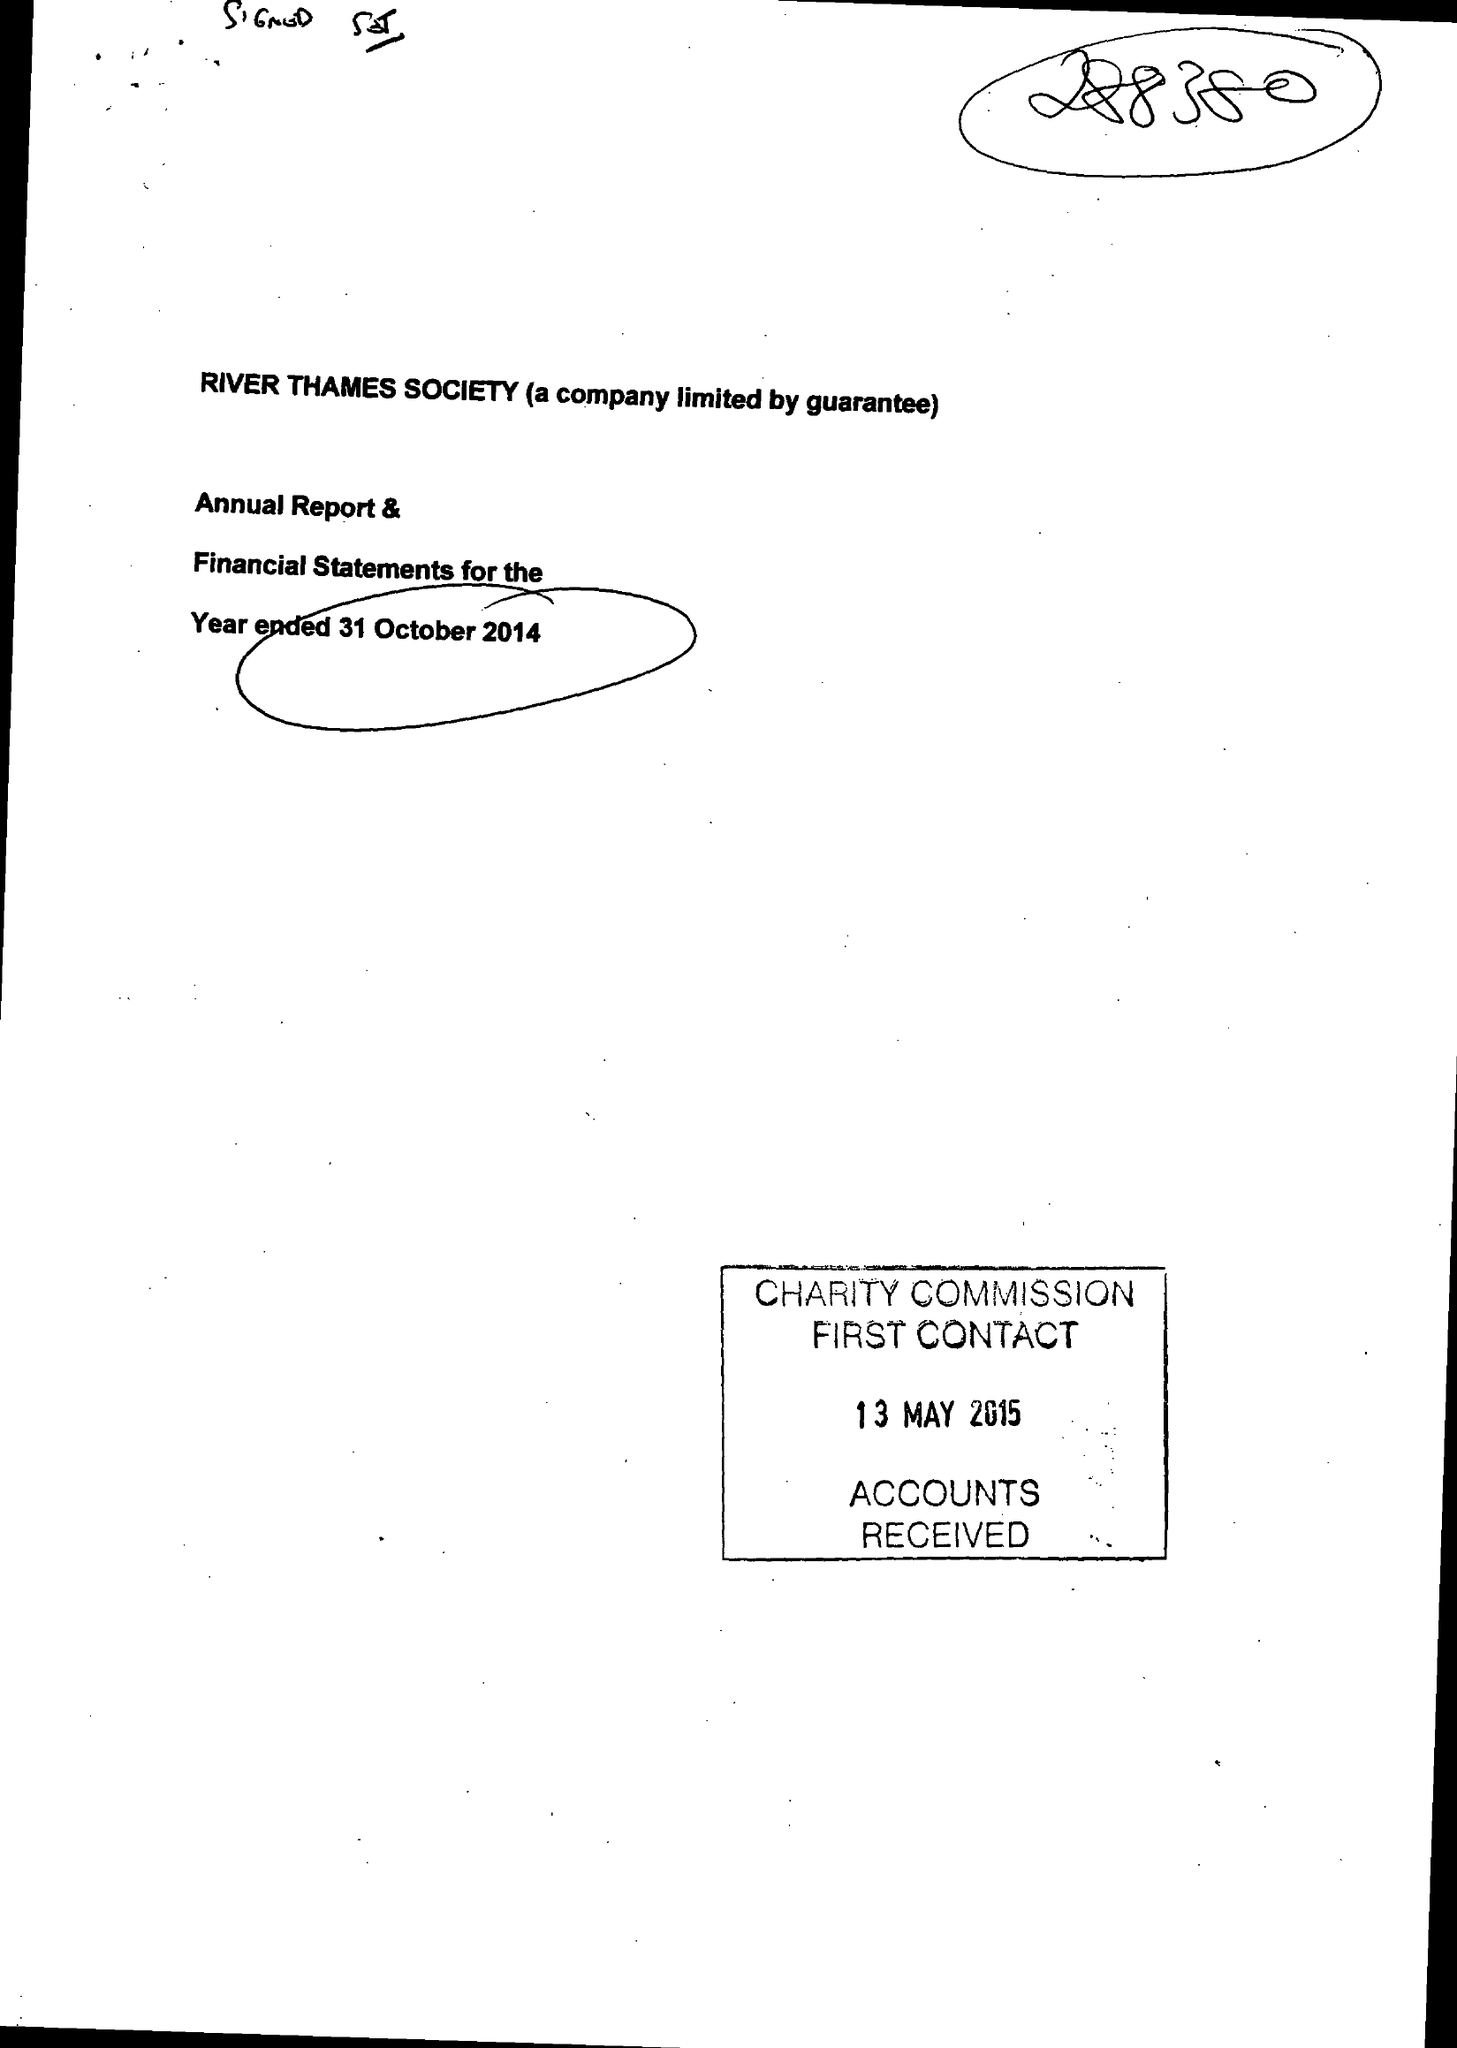What is the value for the address__street_line?
Answer the question using a single word or phrase. 28 BEAUMONT ROAD 